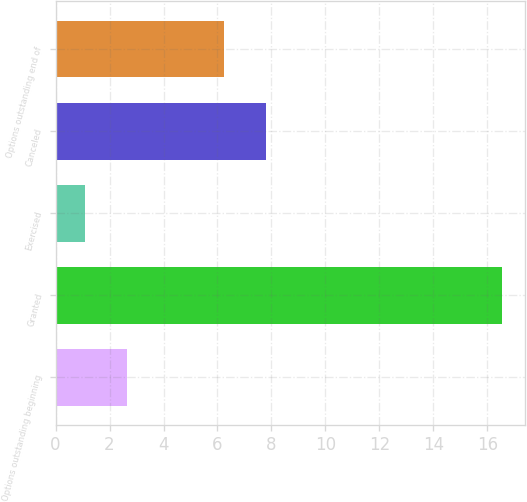Convert chart to OTSL. <chart><loc_0><loc_0><loc_500><loc_500><bar_chart><fcel>Options outstanding beginning<fcel>Granted<fcel>Exercised<fcel>Canceled<fcel>Options outstanding end of<nl><fcel>2.65<fcel>16.55<fcel>1.1<fcel>7.79<fcel>6.25<nl></chart> 